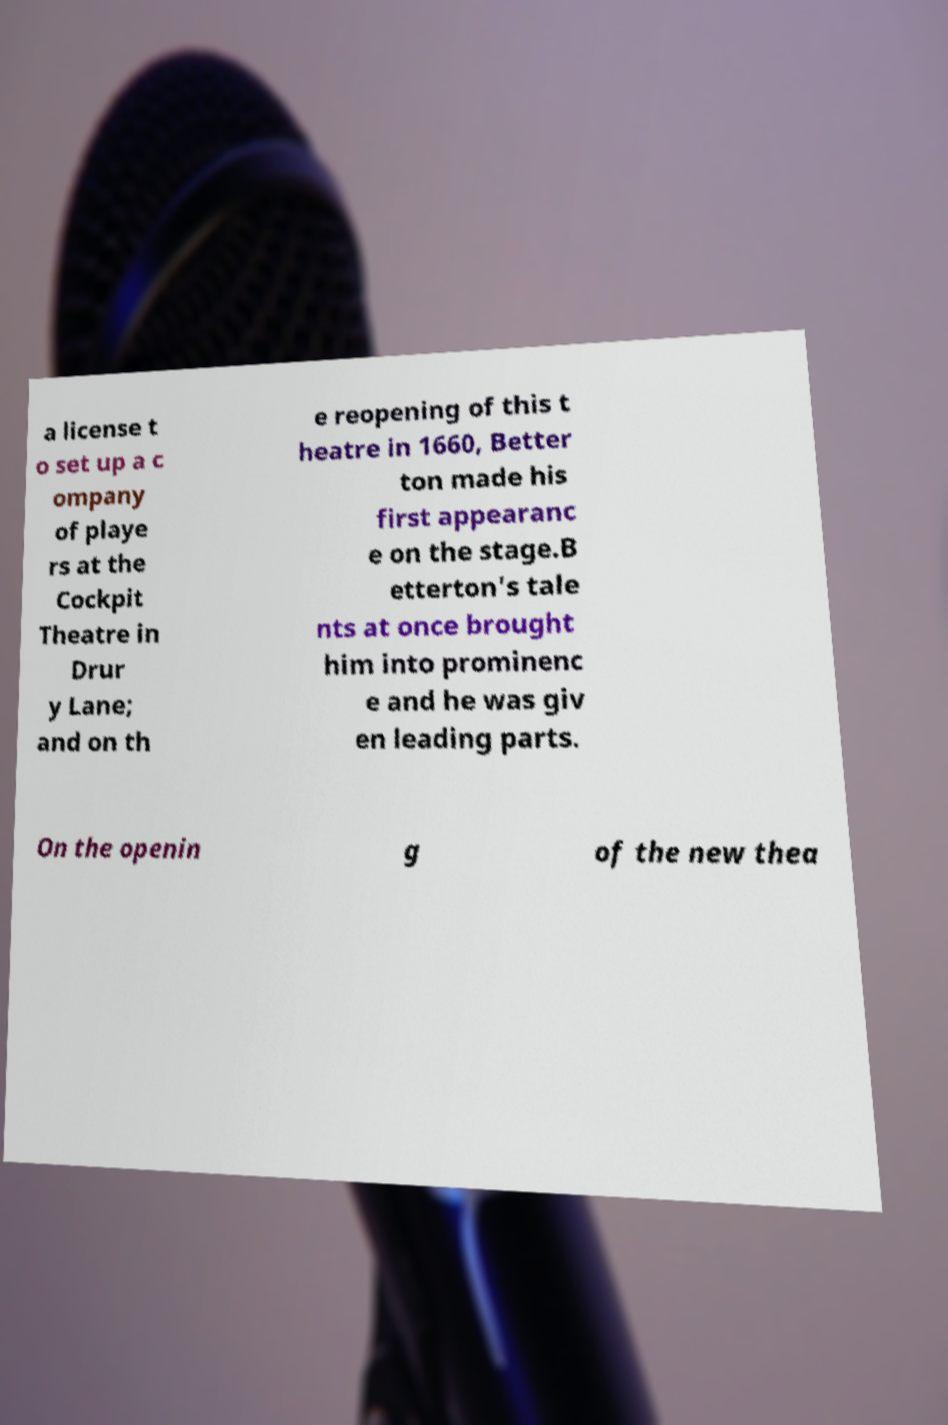Please read and relay the text visible in this image. What does it say? a license t o set up a c ompany of playe rs at the Cockpit Theatre in Drur y Lane; and on th e reopening of this t heatre in 1660, Better ton made his first appearanc e on the stage.B etterton's tale nts at once brought him into prominenc e and he was giv en leading parts. On the openin g of the new thea 